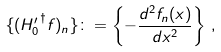<formula> <loc_0><loc_0><loc_500><loc_500>\{ ( { H _ { 0 } ^ { \prime } } ^ { \dagger } { f } ) _ { n } \} \colon = \left \{ - \frac { d ^ { 2 } f _ { n } ( x ) } { d x ^ { 2 } } \right \} \, ,</formula> 